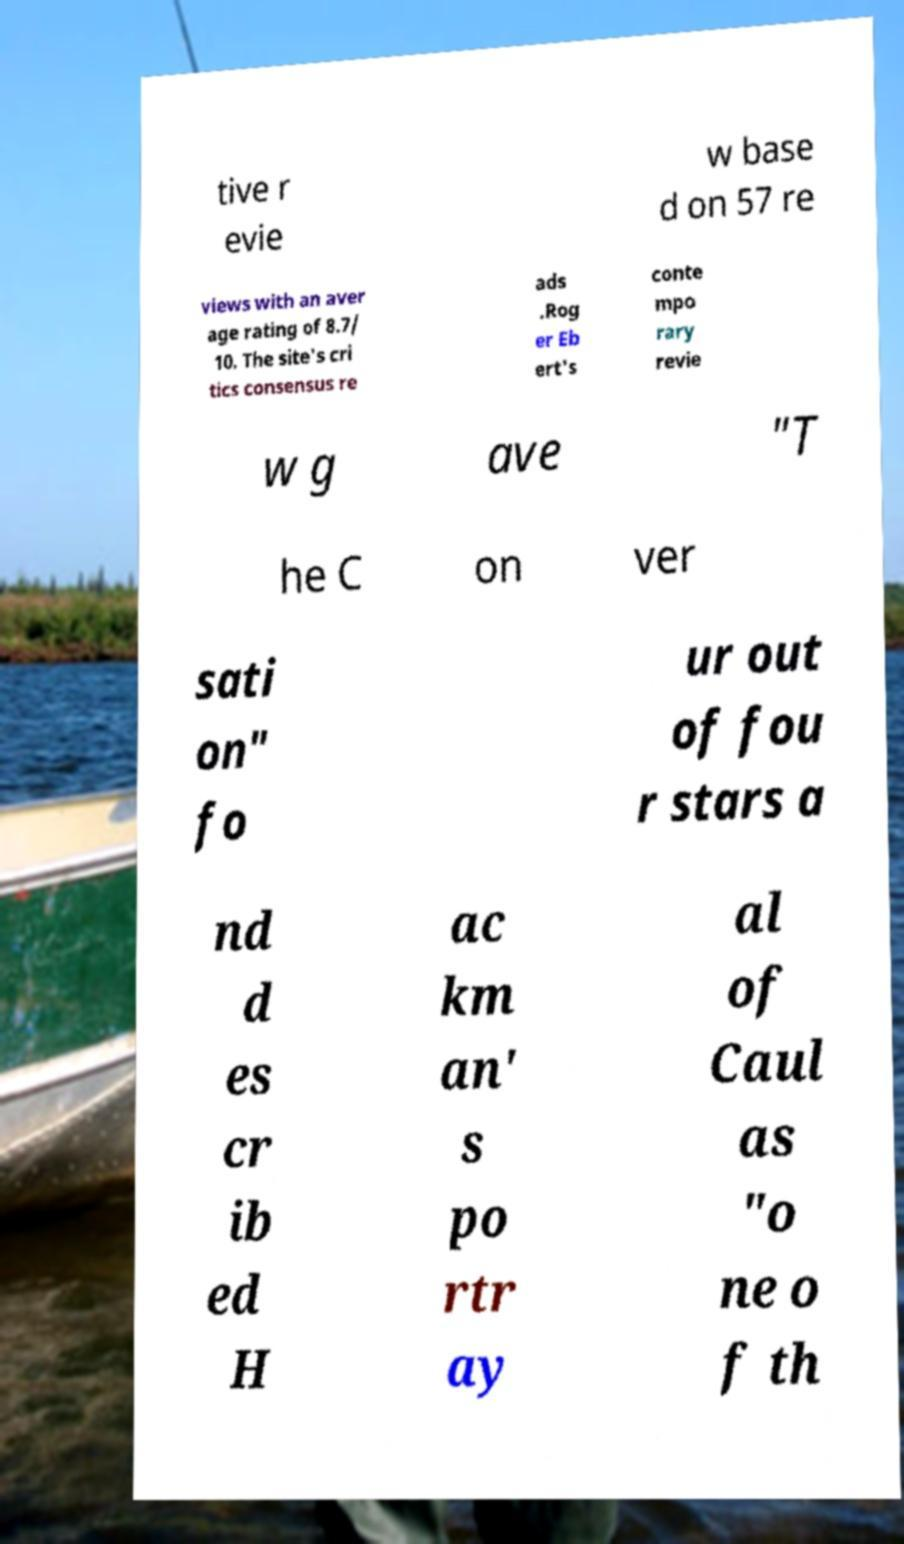I need the written content from this picture converted into text. Can you do that? tive r evie w base d on 57 re views with an aver age rating of 8.7/ 10. The site's cri tics consensus re ads .Rog er Eb ert's conte mpo rary revie w g ave "T he C on ver sati on" fo ur out of fou r stars a nd d es cr ib ed H ac km an' s po rtr ay al of Caul as "o ne o f th 